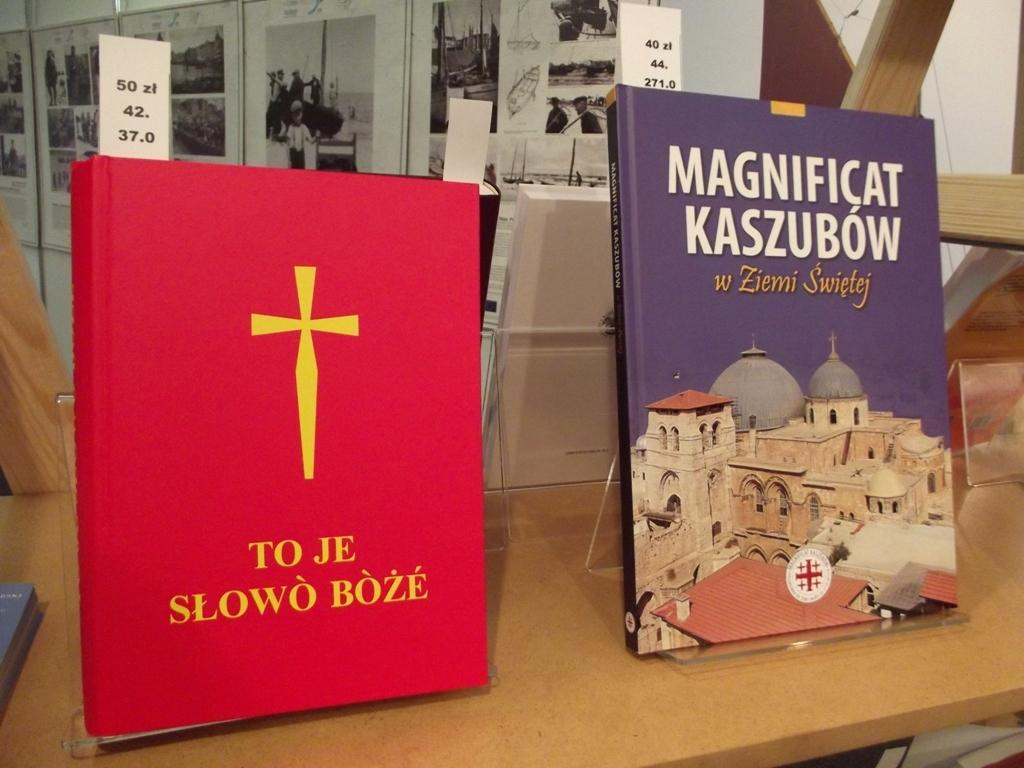Provide a one-sentence caption for the provided image. A red book with a cross and a purple book titled Magnificat Kaszbow are displayed on the shelf. 